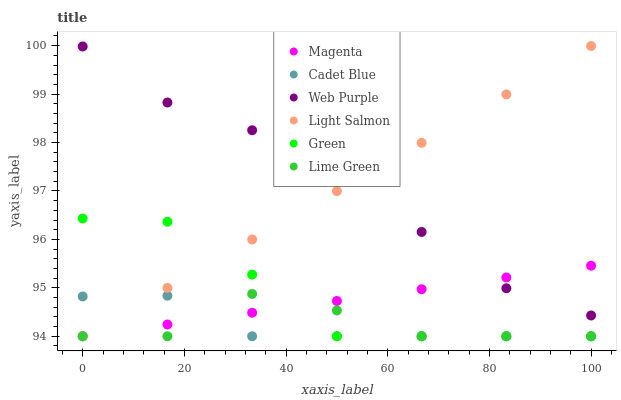Does Cadet Blue have the minimum area under the curve?
Answer yes or no. Yes. Does Web Purple have the maximum area under the curve?
Answer yes or no. Yes. Does Web Purple have the minimum area under the curve?
Answer yes or no. No. Does Cadet Blue have the maximum area under the curve?
Answer yes or no. No. Is Magenta the smoothest?
Answer yes or no. Yes. Is Lime Green the roughest?
Answer yes or no. Yes. Is Cadet Blue the smoothest?
Answer yes or no. No. Is Cadet Blue the roughest?
Answer yes or no. No. Does Light Salmon have the lowest value?
Answer yes or no. Yes. Does Web Purple have the lowest value?
Answer yes or no. No. Does Light Salmon have the highest value?
Answer yes or no. Yes. Does Web Purple have the highest value?
Answer yes or no. No. Is Lime Green less than Web Purple?
Answer yes or no. Yes. Is Web Purple greater than Green?
Answer yes or no. Yes. Does Cadet Blue intersect Magenta?
Answer yes or no. Yes. Is Cadet Blue less than Magenta?
Answer yes or no. No. Is Cadet Blue greater than Magenta?
Answer yes or no. No. Does Lime Green intersect Web Purple?
Answer yes or no. No. 